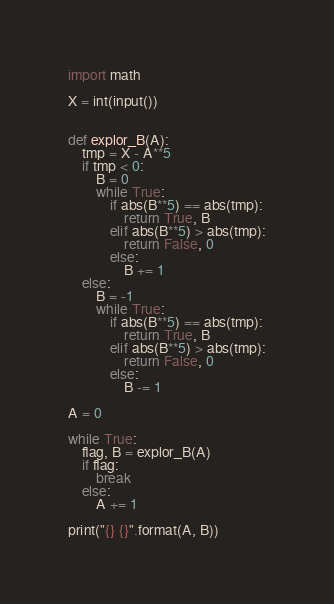<code> <loc_0><loc_0><loc_500><loc_500><_Python_>import math

X = int(input())


def explor_B(A):
    tmp = X - A**5
    if tmp < 0:
        B = 0
        while True:
            if abs(B**5) == abs(tmp):
                return True, B
            elif abs(B**5) > abs(tmp):
                return False, 0
            else:
                B += 1  
    else:
        B = -1
        while True:
            if abs(B**5) == abs(tmp):
                return True, B
            elif abs(B**5) > abs(tmp):
                return False, 0
            else:
                B -= 1  

A = 0

while True:
    flag, B = explor_B(A)
    if flag:
        break
    else:
        A += 1

print("{} {}".format(A, B))
</code> 